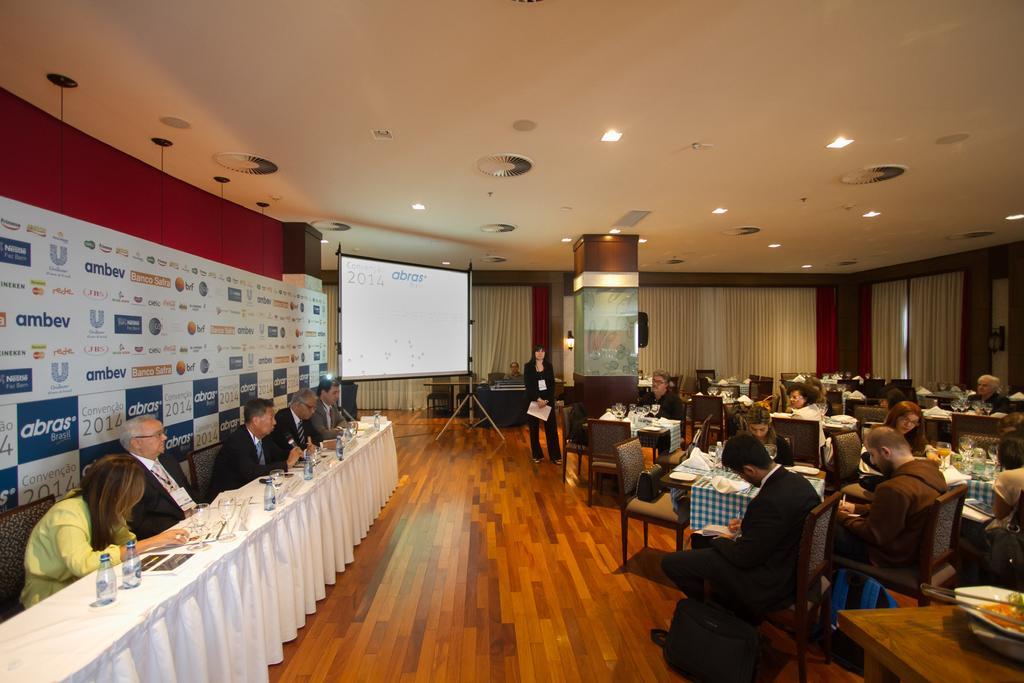Can you describe this image briefly? As we can see in the image there is a wall, screen, few people sitting over here and there is a table. On table there are bottles and glasses. 